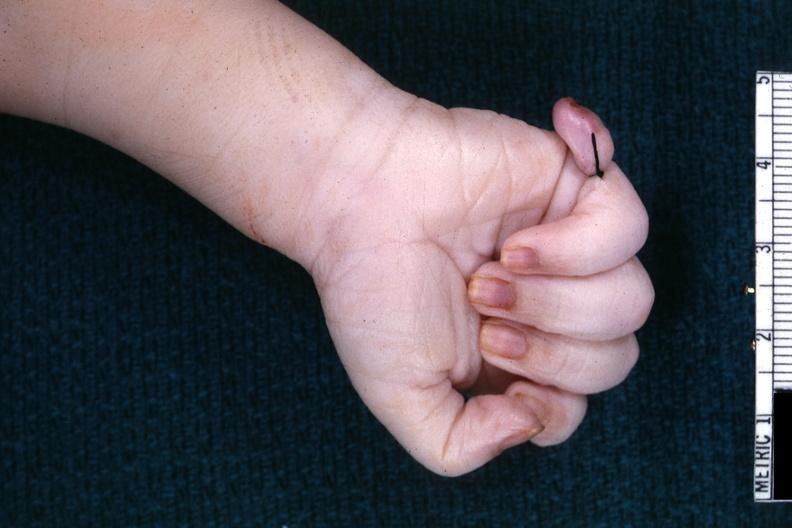what are present?
Answer the question using a single word or phrase. Extremities 